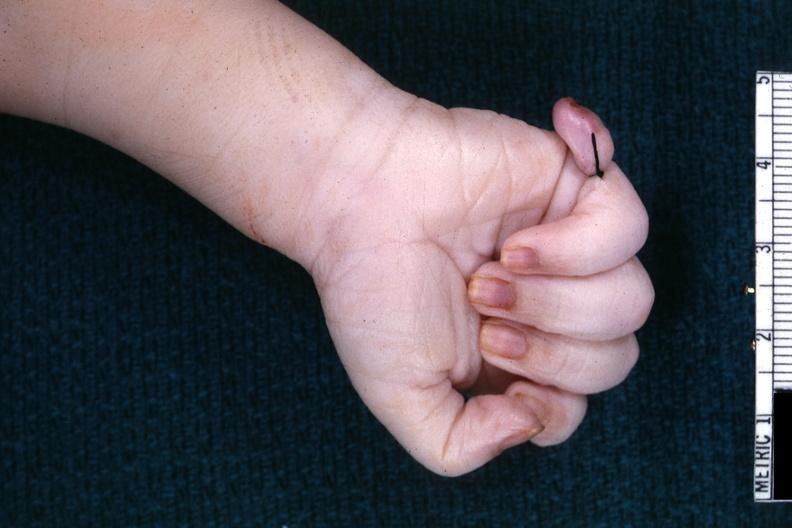what are present?
Answer the question using a single word or phrase. Extremities 